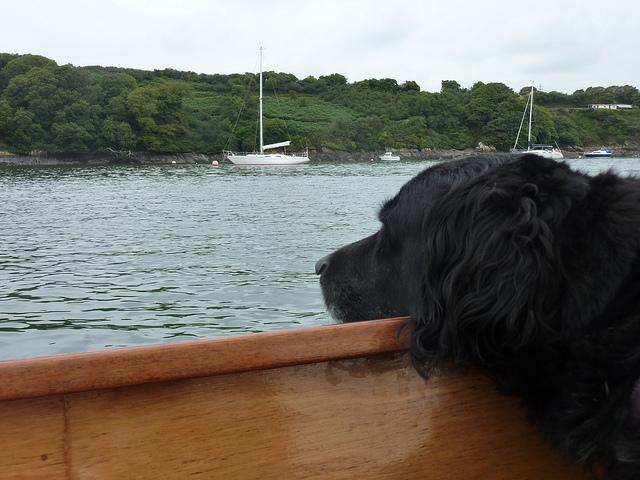What is causing the dog to rest his head on the side of the boat? tired 